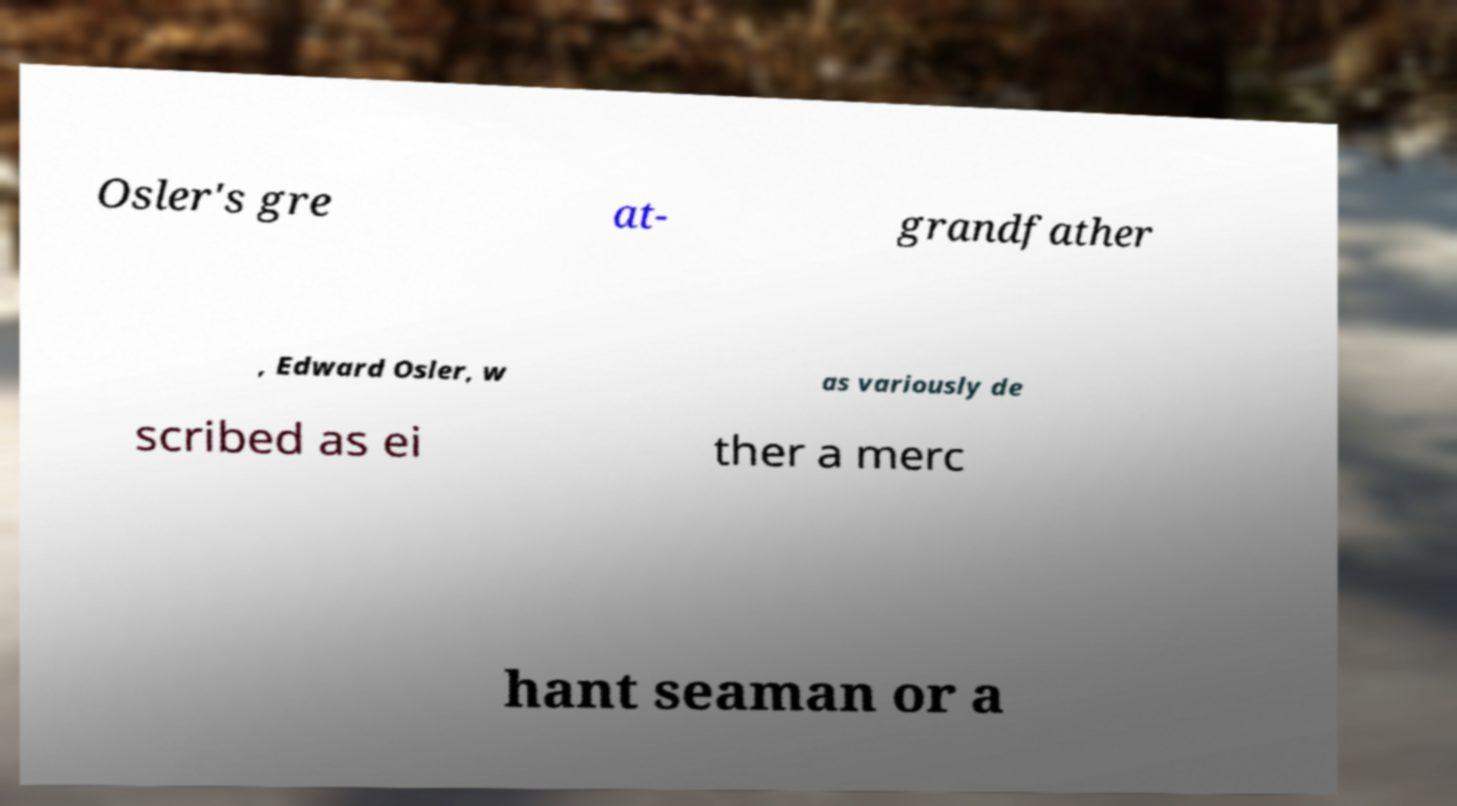Could you extract and type out the text from this image? Osler's gre at- grandfather , Edward Osler, w as variously de scribed as ei ther a merc hant seaman or a 